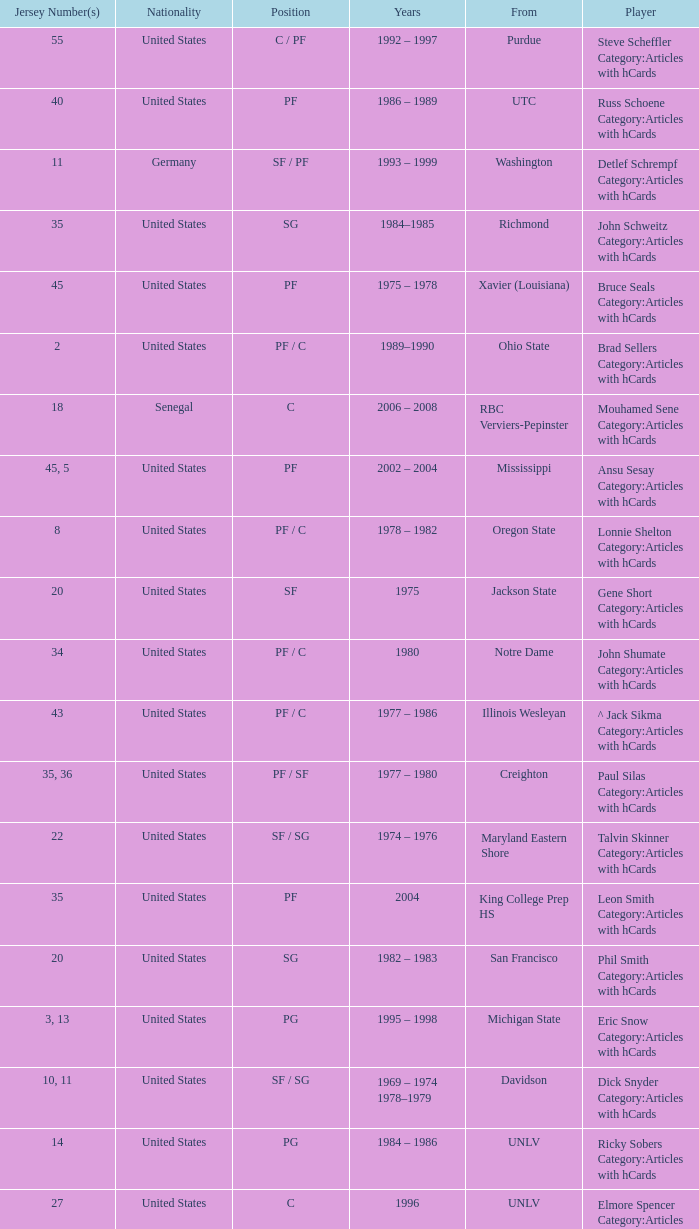What nationality is the player from Oregon State? United States. 